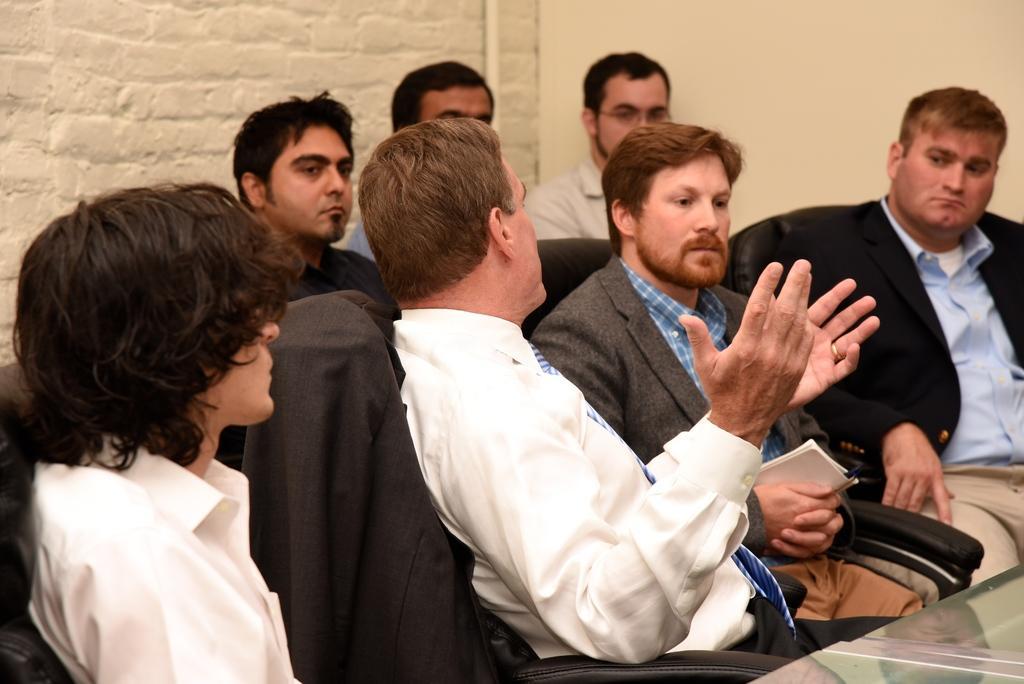In one or two sentences, can you explain what this image depicts? On the left there is a woman and few men sitting on the chair at the table and among them one man is holding a book in his hands. In the background there is a wall. 